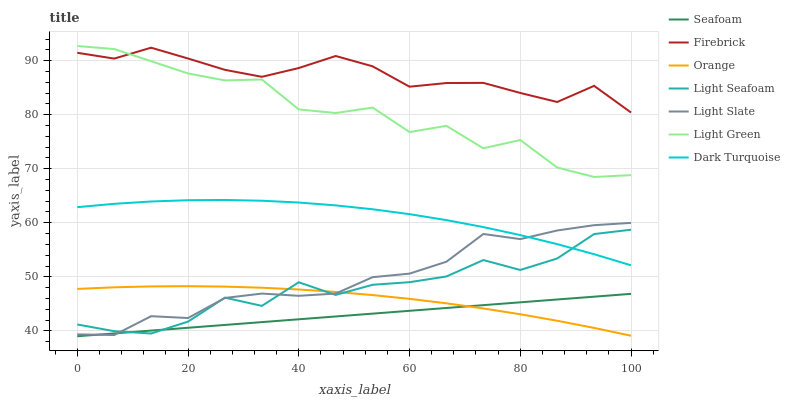Does Seafoam have the minimum area under the curve?
Answer yes or no. Yes. Does Firebrick have the maximum area under the curve?
Answer yes or no. Yes. Does Dark Turquoise have the minimum area under the curve?
Answer yes or no. No. Does Dark Turquoise have the maximum area under the curve?
Answer yes or no. No. Is Seafoam the smoothest?
Answer yes or no. Yes. Is Light Green the roughest?
Answer yes or no. Yes. Is Dark Turquoise the smoothest?
Answer yes or no. No. Is Dark Turquoise the roughest?
Answer yes or no. No. Does Seafoam have the lowest value?
Answer yes or no. Yes. Does Dark Turquoise have the lowest value?
Answer yes or no. No. Does Light Green have the highest value?
Answer yes or no. Yes. Does Dark Turquoise have the highest value?
Answer yes or no. No. Is Dark Turquoise less than Firebrick?
Answer yes or no. Yes. Is Dark Turquoise greater than Orange?
Answer yes or no. Yes. Does Orange intersect Light Seafoam?
Answer yes or no. Yes. Is Orange less than Light Seafoam?
Answer yes or no. No. Is Orange greater than Light Seafoam?
Answer yes or no. No. Does Dark Turquoise intersect Firebrick?
Answer yes or no. No. 